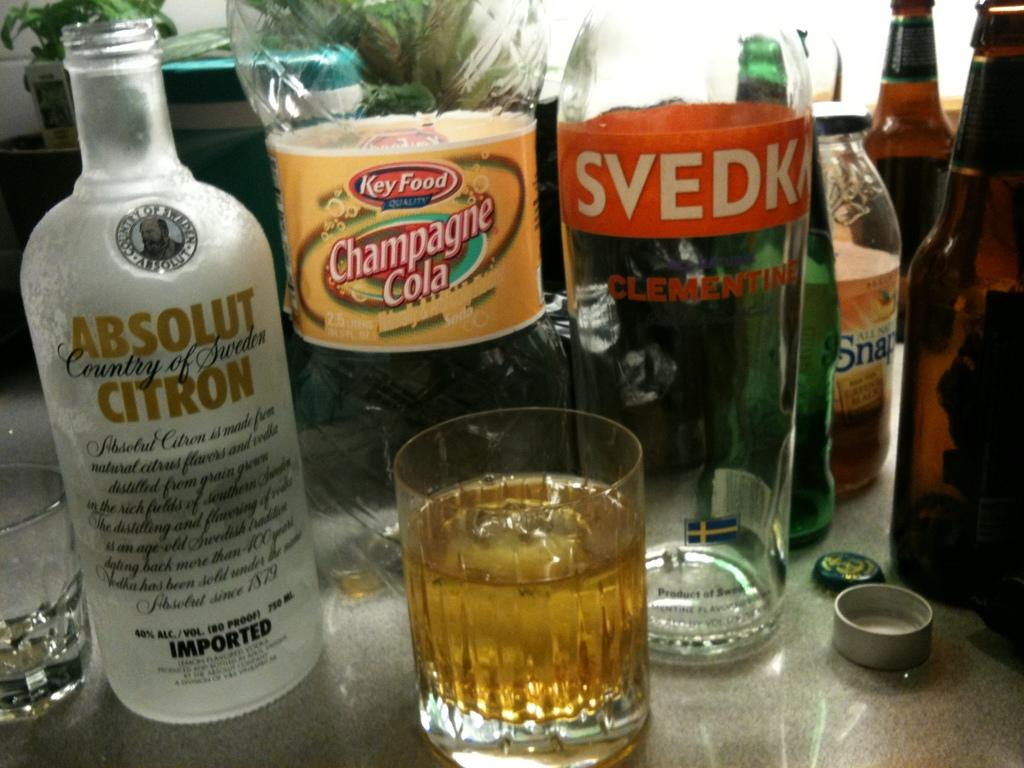What type of furniture is present in the image? There is a table in the image. What is placed on the table? There is a glass with liquid, bottles, caps, a box, and a house plant on the table. What might be used for drinking or pouring in the image? The glass with liquid and the bottles on the table might be used for drinking or pouring. What type of plant is on the table in the image? There is a house plant on the table. Can you tell me how many beggars are visible in the image? There are no beggars present in the image; it features a table with various objects on it. What type of reading material is on the table in the image? There is no reading material present in the image; it features a table with various objects, including a glass with liquid, bottles, caps, a box, and a house plant. 